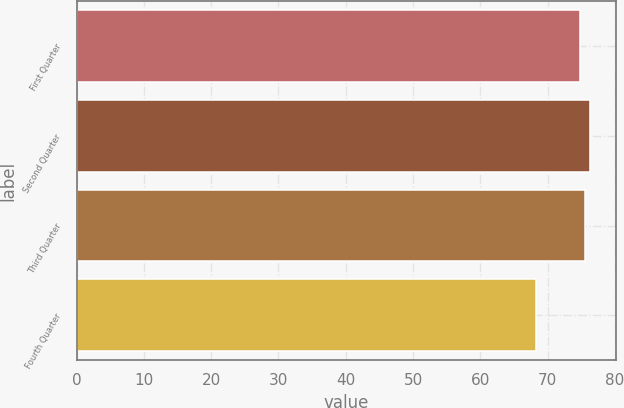Convert chart to OTSL. <chart><loc_0><loc_0><loc_500><loc_500><bar_chart><fcel>First Quarter<fcel>Second Quarter<fcel>Third Quarter<fcel>Fourth Quarter<nl><fcel>74.83<fcel>76.31<fcel>75.57<fcel>68.31<nl></chart> 